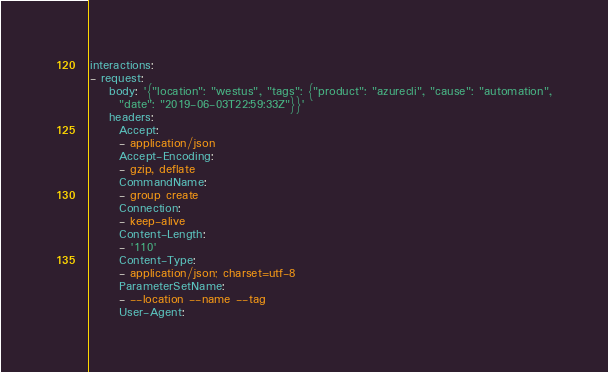Convert code to text. <code><loc_0><loc_0><loc_500><loc_500><_YAML_>interactions:
- request:
    body: '{"location": "westus", "tags": {"product": "azurecli", "cause": "automation",
      "date": "2019-06-03T22:59:33Z"}}'
    headers:
      Accept:
      - application/json
      Accept-Encoding:
      - gzip, deflate
      CommandName:
      - group create
      Connection:
      - keep-alive
      Content-Length:
      - '110'
      Content-Type:
      - application/json; charset=utf-8
      ParameterSetName:
      - --location --name --tag
      User-Agent:</code> 